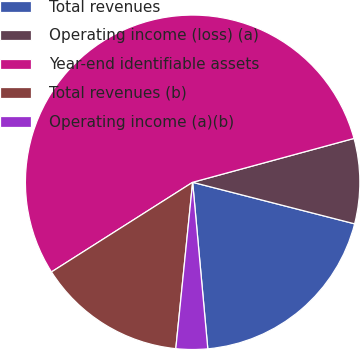Convert chart to OTSL. <chart><loc_0><loc_0><loc_500><loc_500><pie_chart><fcel>Total revenues<fcel>Operating income (loss) (a)<fcel>Year-end identifiable assets<fcel>Total revenues (b)<fcel>Operating income (a)(b)<nl><fcel>19.56%<fcel>8.22%<fcel>54.78%<fcel>14.39%<fcel>3.05%<nl></chart> 